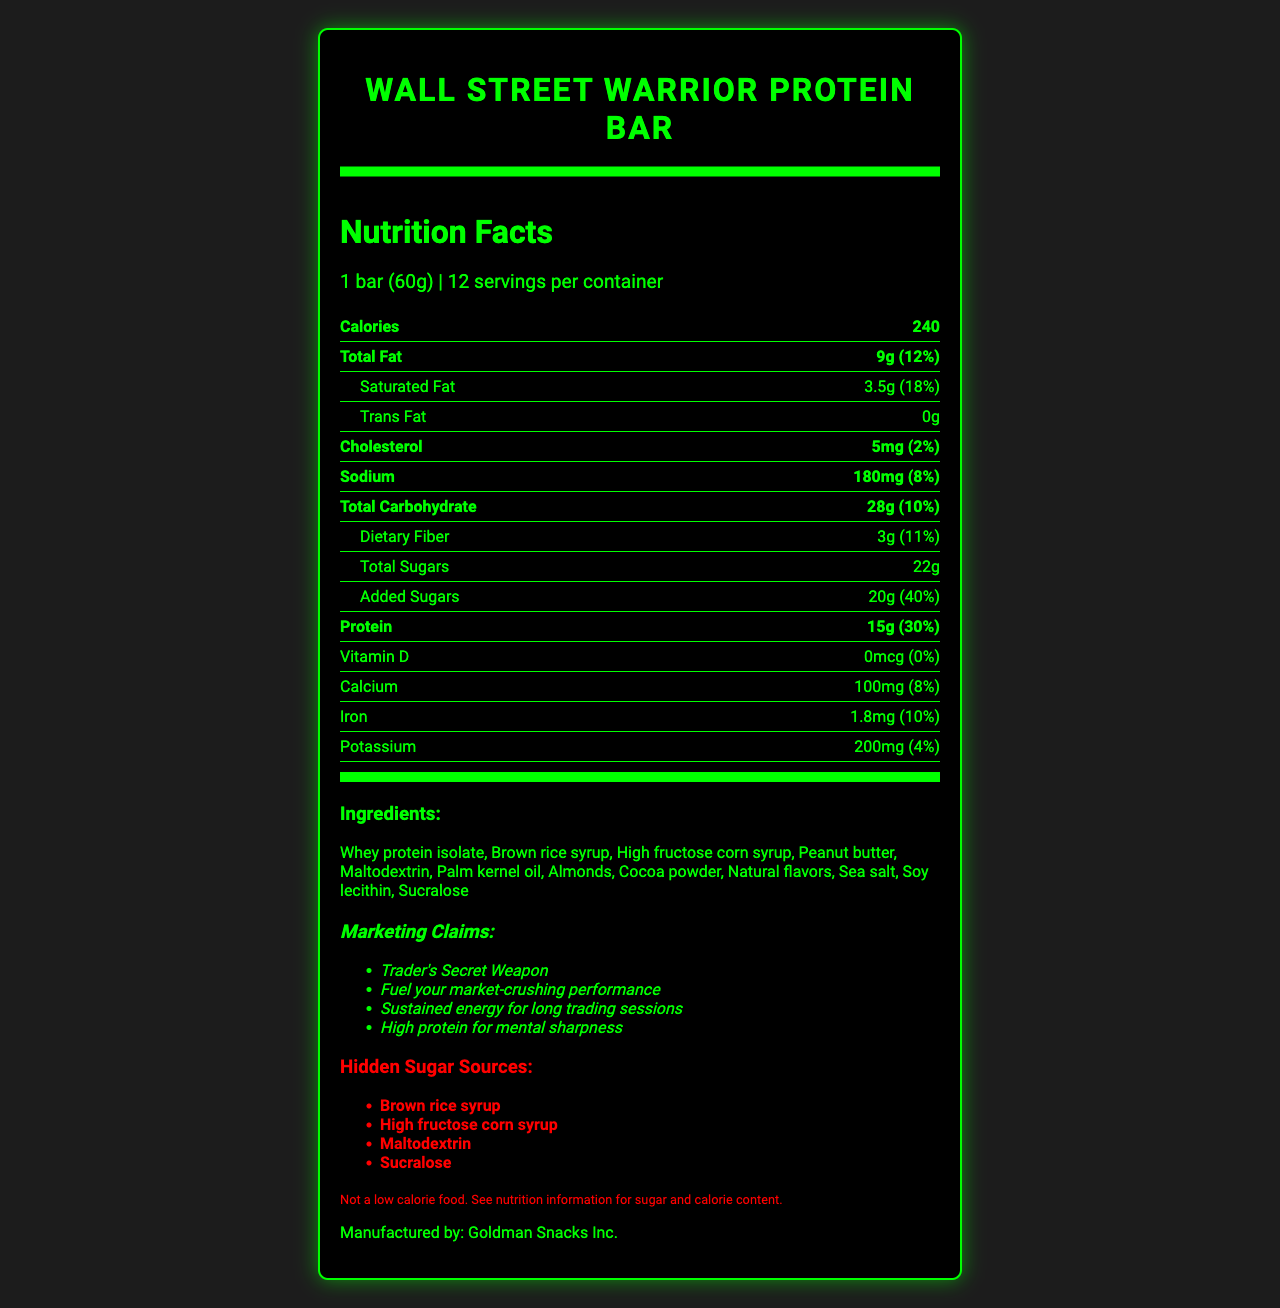what is the serving size of the Wall Street Warrior Protein Bar? The serving size is directly listed at the top of the document under "serving size."
Answer: 1 bar (60g) what is the amount of total sugars in one serving? The amount of total sugars is listed under the "Total Sugars" row in the Nutrition Facts section.
Answer: 22g how many calories are in one bar? The calories are listed in bold at the top of the Nutrition Facts section.
Answer: 240 what are the hidden sugar sources mentioned in the document? The hidden sugar sources are listed in the section titled "Hidden Sugar Sources."
Answer: Brown rice syrup, High fructose corn syrup, Maltodextrin, Sucralose what is the protein content of the Wall Street Warrior Protein Bar? The protein content is listed in bold under the "Protein" row in the Nutrition Facts section.
Answer: 15g what is the percentage of daily value for saturated fat in one serving? A. 12% B. 18% C. 20% The percentage of daily value for saturated fat (3.5g) is listed as 18%.
Answer: B which of the following is not an ingredient in the Wall Street Warrior Protein Bar? A. Whey protein isolate B. High fructose corn syrup C. Rice flour D. Peanut butter Rice flour is not listed in the ingredients section, while whey protein isolate, high fructose corn syrup, and peanut butter are listed.
Answer: C is the Wall Street Warrior Protein Bar a low calorie food? According to the disclaimer, it states "Not a low calorie food."
Answer: No summarize the main marketing claims of the Wall Street Warrior Protein Bar. These claims are listed under the section titled "Marketing Claims" in italics.
Answer: The bar is marketed as a "Trader's Secret Weapon" that provides fuel for market-crushing performance, sustained energy for long trading sessions, and high protein for mental sharpness. what is the total daily value percentage of added sugars in one serving of the protein bar? The daily value percentage for added sugars (20g) is listed as 40% under the "Added Sugars" row.
Answer: 40% how much calcium is in one serving of the Wall Street Warrior Protein Bar? The amount of calcium is listed under the "Calcium" row in the Nutrition Facts section.
Answer: 100mg what allergens does the Wall Street Warrior Protein Bar contain? The allergens are listed in the section titled "Allergens."
Answer: Milk, peanuts, almonds, and soy how many servings are there in one container of Wall Street Warrior Protein Bar? The number of servings per container is listed near the top of the Nutrition Facts section.
Answer: 12 servings how much sodium is in one serving of the protein bar? The amount of sodium is listed under the "Sodium" row in the Nutrition Facts section.
Answer: 180mg who is the manufacturer of the Wall Street Warrior Protein Bar? The manufacturer is mentioned at the end of the document.
Answer: Goldman Snacks Inc. what is the potassium content in one serving of the Wall Street Warrior Protein Bar? The potassium content is listed under the "Potassium" row in the Nutrition Facts section.
Answer: 200mg which ingredient is not clearly identified as a hidden sugar source but adds sugar to the product? Peanut butter is part of the ingredient list and can contain added sugars, but it is not listed as a hidden sugar source.
Answer: Peanut butter how does the font style and color scheme relate to the theme of the document? The styling choices are consistent with the product’s aim to convey an image of high performance and energy for traders.
Answer: The document uses a neon green and black color scheme with a digital font, evoking a high-tech and market-oriented theme. what is the percentage of daily value for dietary fiber in one serving of the protein bar? The daily value percentage for dietary fiber (3g) is listed as 11% in the Nutrition Facts section.
Answer: 11% how many vitamins and minerals are listed in the nutrition facts? Vitamin D, calcium, iron, and potassium are listed, although Vitamin D has a daily value of 0%.
Answer: 4 what is the source of maltodextrin mentioned in the Wall Street Warrior Protein Bar? The document lists maltodextrin as an ingredient but does not specify its source.
Answer: Not enough information 